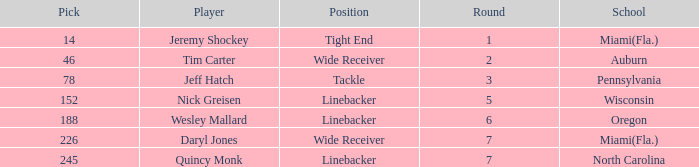Can you give me this table as a dict? {'header': ['Pick', 'Player', 'Position', 'Round', 'School'], 'rows': [['14', 'Jeremy Shockey', 'Tight End', '1', 'Miami(Fla.)'], ['46', 'Tim Carter', 'Wide Receiver', '2', 'Auburn'], ['78', 'Jeff Hatch', 'Tackle', '3', 'Pennsylvania'], ['152', 'Nick Greisen', 'Linebacker', '5', 'Wisconsin'], ['188', 'Wesley Mallard', 'Linebacker', '6', 'Oregon'], ['226', 'Daryl Jones', 'Wide Receiver', '7', 'Miami(Fla.)'], ['245', 'Quincy Monk', 'Linebacker', '7', 'North Carolina']]} From what school was the linebacker that had a pick less than 245 and was drafted in round 6? Oregon. 